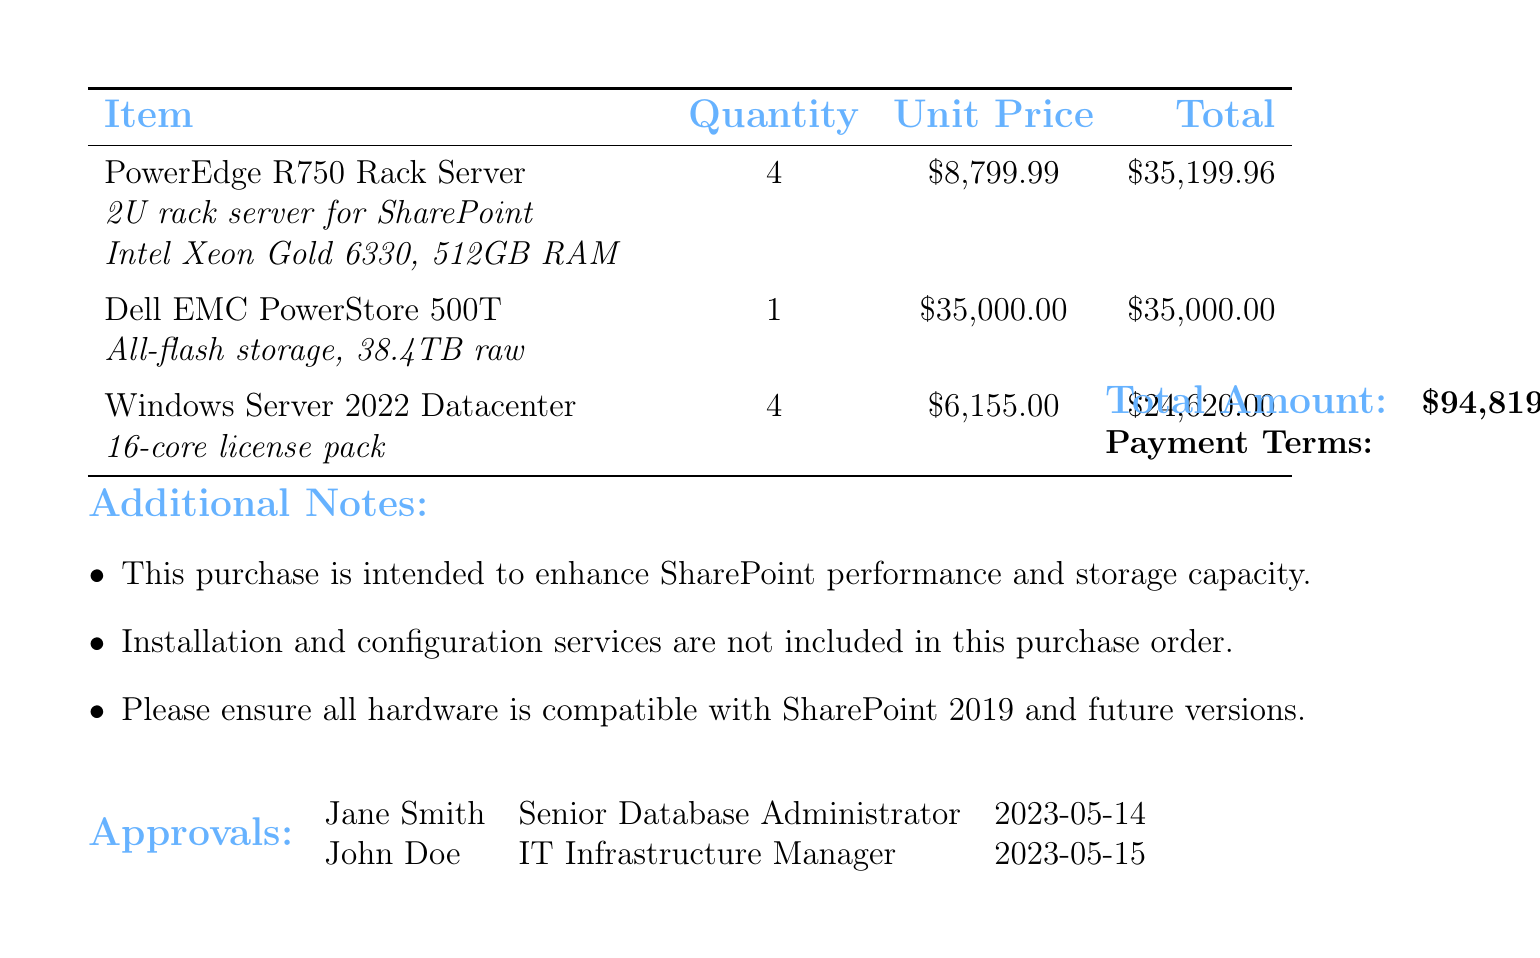What is the order number? The order number is indicated prominently at the top of the document.
Answer: PO-2023-05-15-001 Who is the vendor? The vendor is listed in the document under the relevant section for vendor information.
Answer: Dell Technologies How many PowerEdge R750 Rack Servers are ordered? The quantity of PowerEdge R750 Rack Servers is specified in the items section of the document.
Answer: 4 What is the total amount of the purchase order? The total amount is calculated by adding up the total prices of all items in the order.
Answer: 94819.96 What item is intended for high-performance SharePoint data storage? The document specifies items with their descriptions clearly related to their functions.
Answer: Dell EMC PowerStore 500T What are the payment terms? The payment terms are listed explicitly in the purchase order details.
Answer: Net 30 How many approvals are listed in the document? The number of approvals can be counted from the approvals section of the document.
Answer: 2 What is one additional note mentioned in the document? Additional notes are provided to clarify aspects of the purchase, indicating specific requirements or exclusions.
Answer: This purchase is intended to enhance SharePoint performance and storage capacity What is the effective capacity of the Dell EMC PowerStore 500T? The effective capacity is detailed in the specifications of the item section of the document.
Answer: 100TB+ 